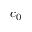Convert formula to latex. <formula><loc_0><loc_0><loc_500><loc_500>c _ { 0 }</formula> 